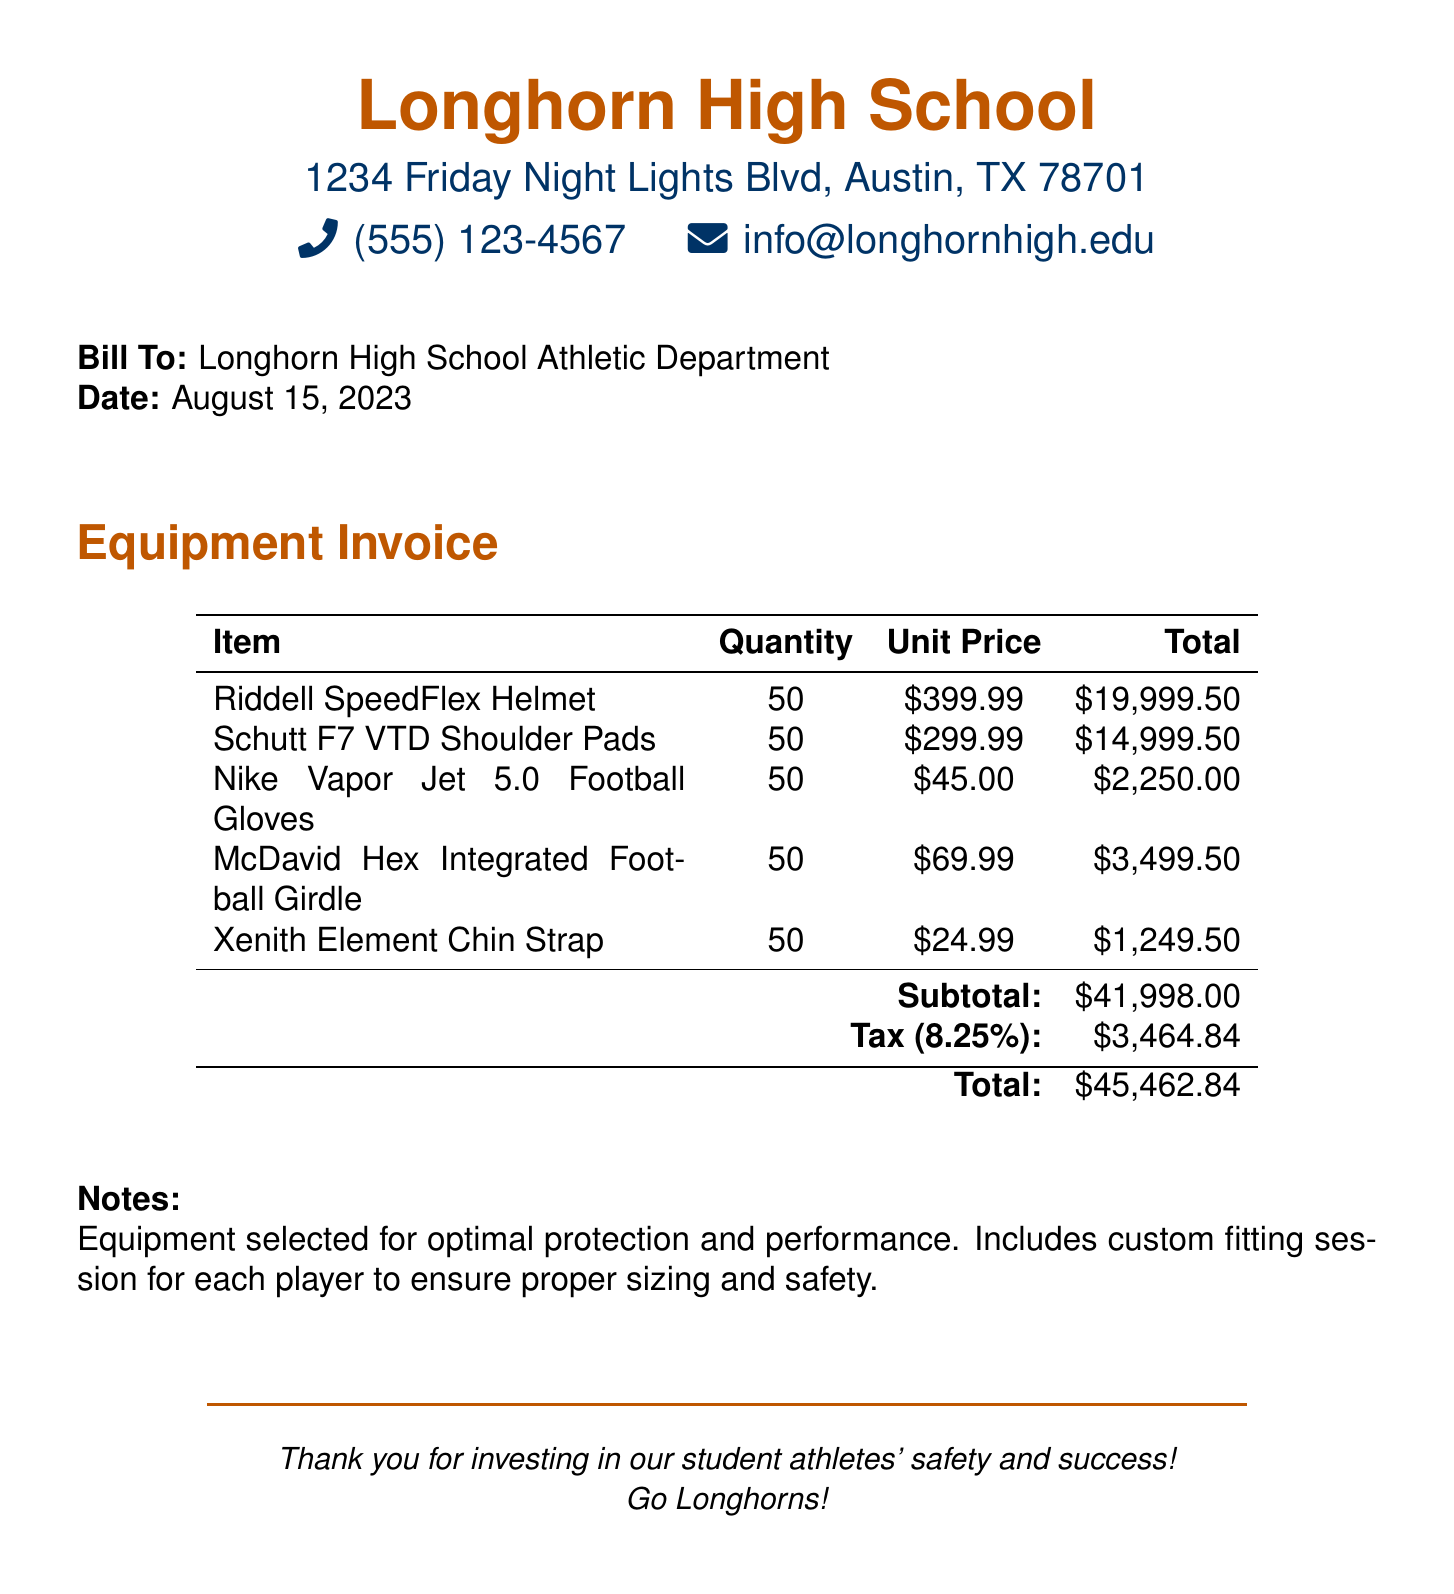what is the date of the bill? The date of the bill is indicated in the document as the issue date, which is August 15, 2023.
Answer: August 15, 2023 how many helmets are being ordered? The number of helmets is provided in the itemized list, showing a quantity of 50 helmets.
Answer: 50 what is the total cost for the shoulder pads? The total cost is calculated by multiplying the quantity of shoulder pads by the unit price, which results in \$14,999.50.
Answer: $14,999.50 what is the subtotal before tax? The subtotal is clearly noted in the document as the sum of all item totals, which is \$41,998.00.
Answer: $41,998.00 what is the tax rate applied to the invoice? The tax rate can be found in the document, which states the tax as 8.25%.
Answer: 8.25% what is the total amount due for the equipment? The total amount due is calculated at the bottom of the document, specifically noted as \$45,462.84.
Answer: $45,462.84 what is included with the equipment selection? Included with the equipment selection is a custom fitting session for each player.
Answer: custom fitting session who is the bill addressed to? The bill is clearly addressed to the Longhorn High School Athletic Department.
Answer: Longhorn High School Athletic Department what is the purpose of this invoice? The purpose of the invoice is to outline the costs associated with new football equipment and protective gear.
Answer: new football equipment and protective gear 